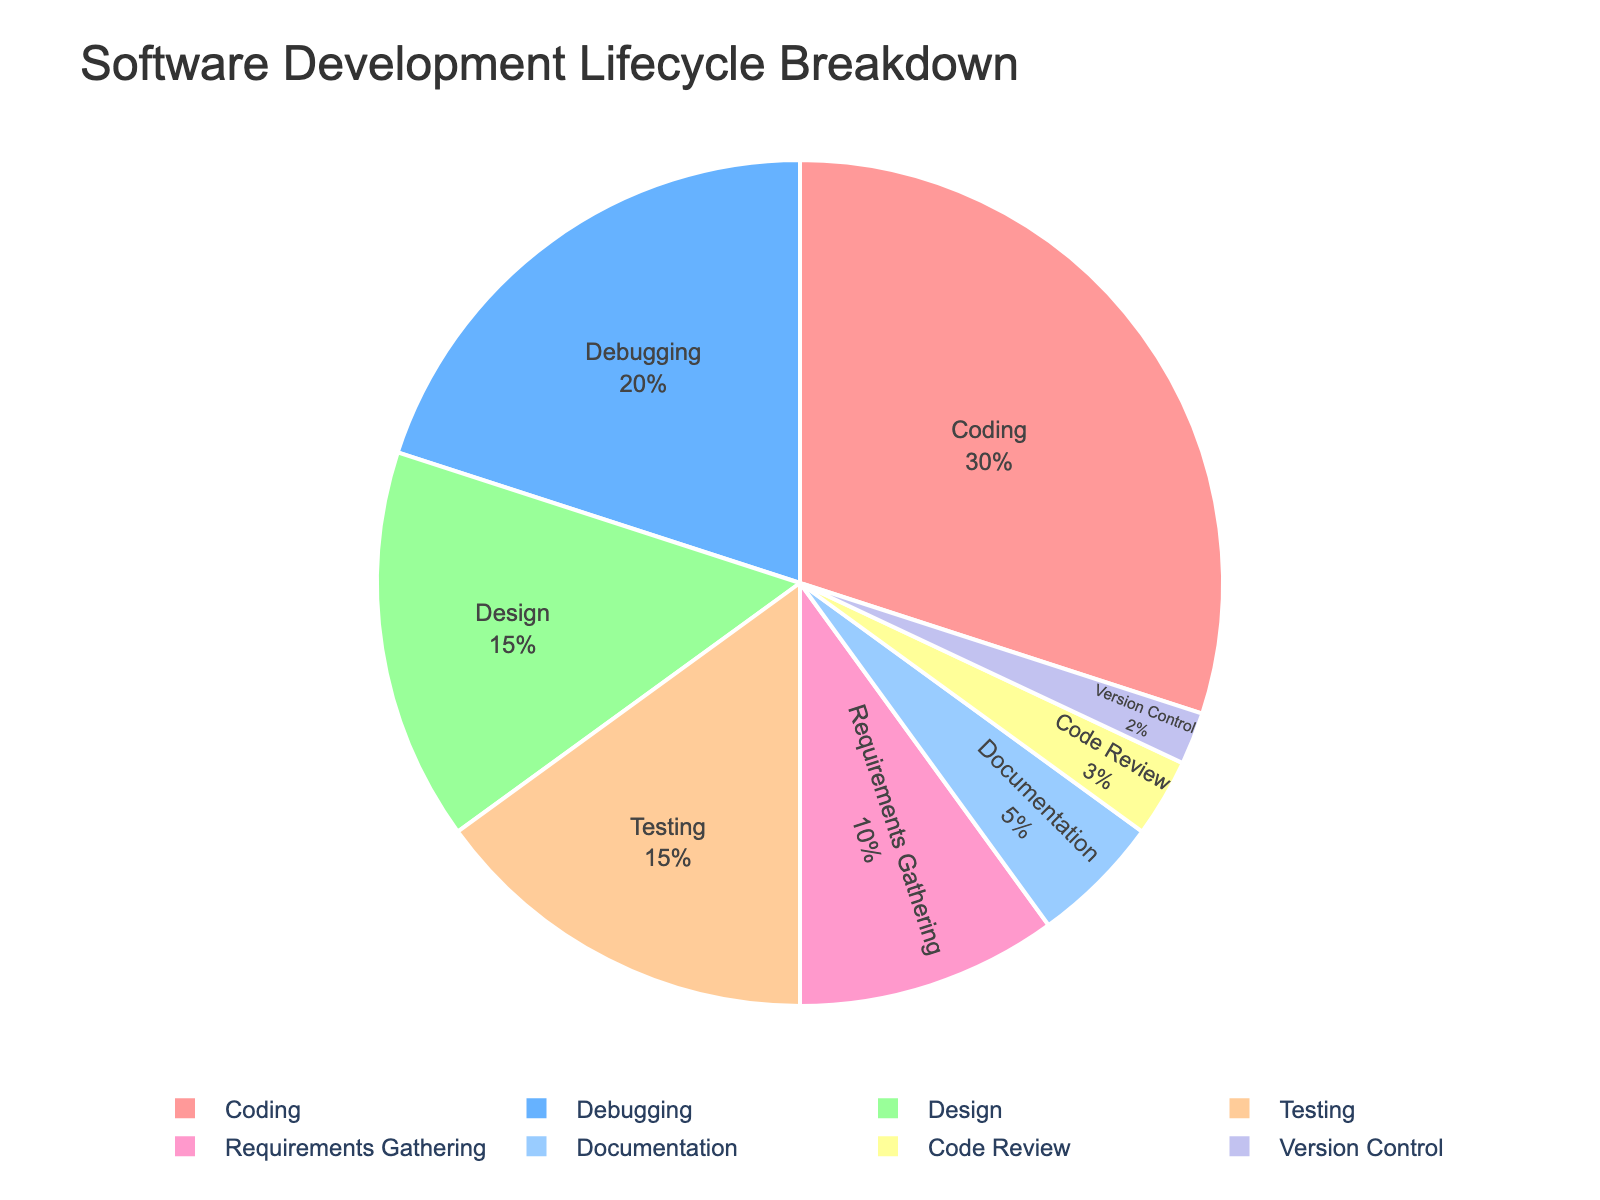What percentage of the total time is spent on Coding and Debugging combined? Combine the percentages for Coding (30%) and Debugging (20%), which results in 30% + 20% = 50%.
Answer: 50% Which phase takes the smallest proportion of time? Identify the smallest percentage value in the pie chart, which is Version Control at 2%.
Answer: Version Control Is more time spent on Testing or on Design? Compare the percentages for Testing (15%) and Design (15%), which are equal.
Answer: Equal What is the sum of the percentages for Documentation, Code Review, and Version Control? Add the percentages for Documentation (5%), Code Review (3%), and Version Control (2%), giving 5% + 3% + 2% = 10%.
Answer: 10% Which phase has the same proportion as Testing? Find the phase with the same percentage as Testing, which is Design, both at 15%.
Answer: Design What is the difference in time spent between Requirements Gathering and Version Control? Subtract the percentage for Version Control (2%) from Requirements Gathering (10%), resulting in 10% - 2% = 8%.
Answer: 8% Which phase uses a blue color in the pie chart? Identify the phase associated with the blue color. Design is represented by blue (the second color in the palette).
Answer: Design 